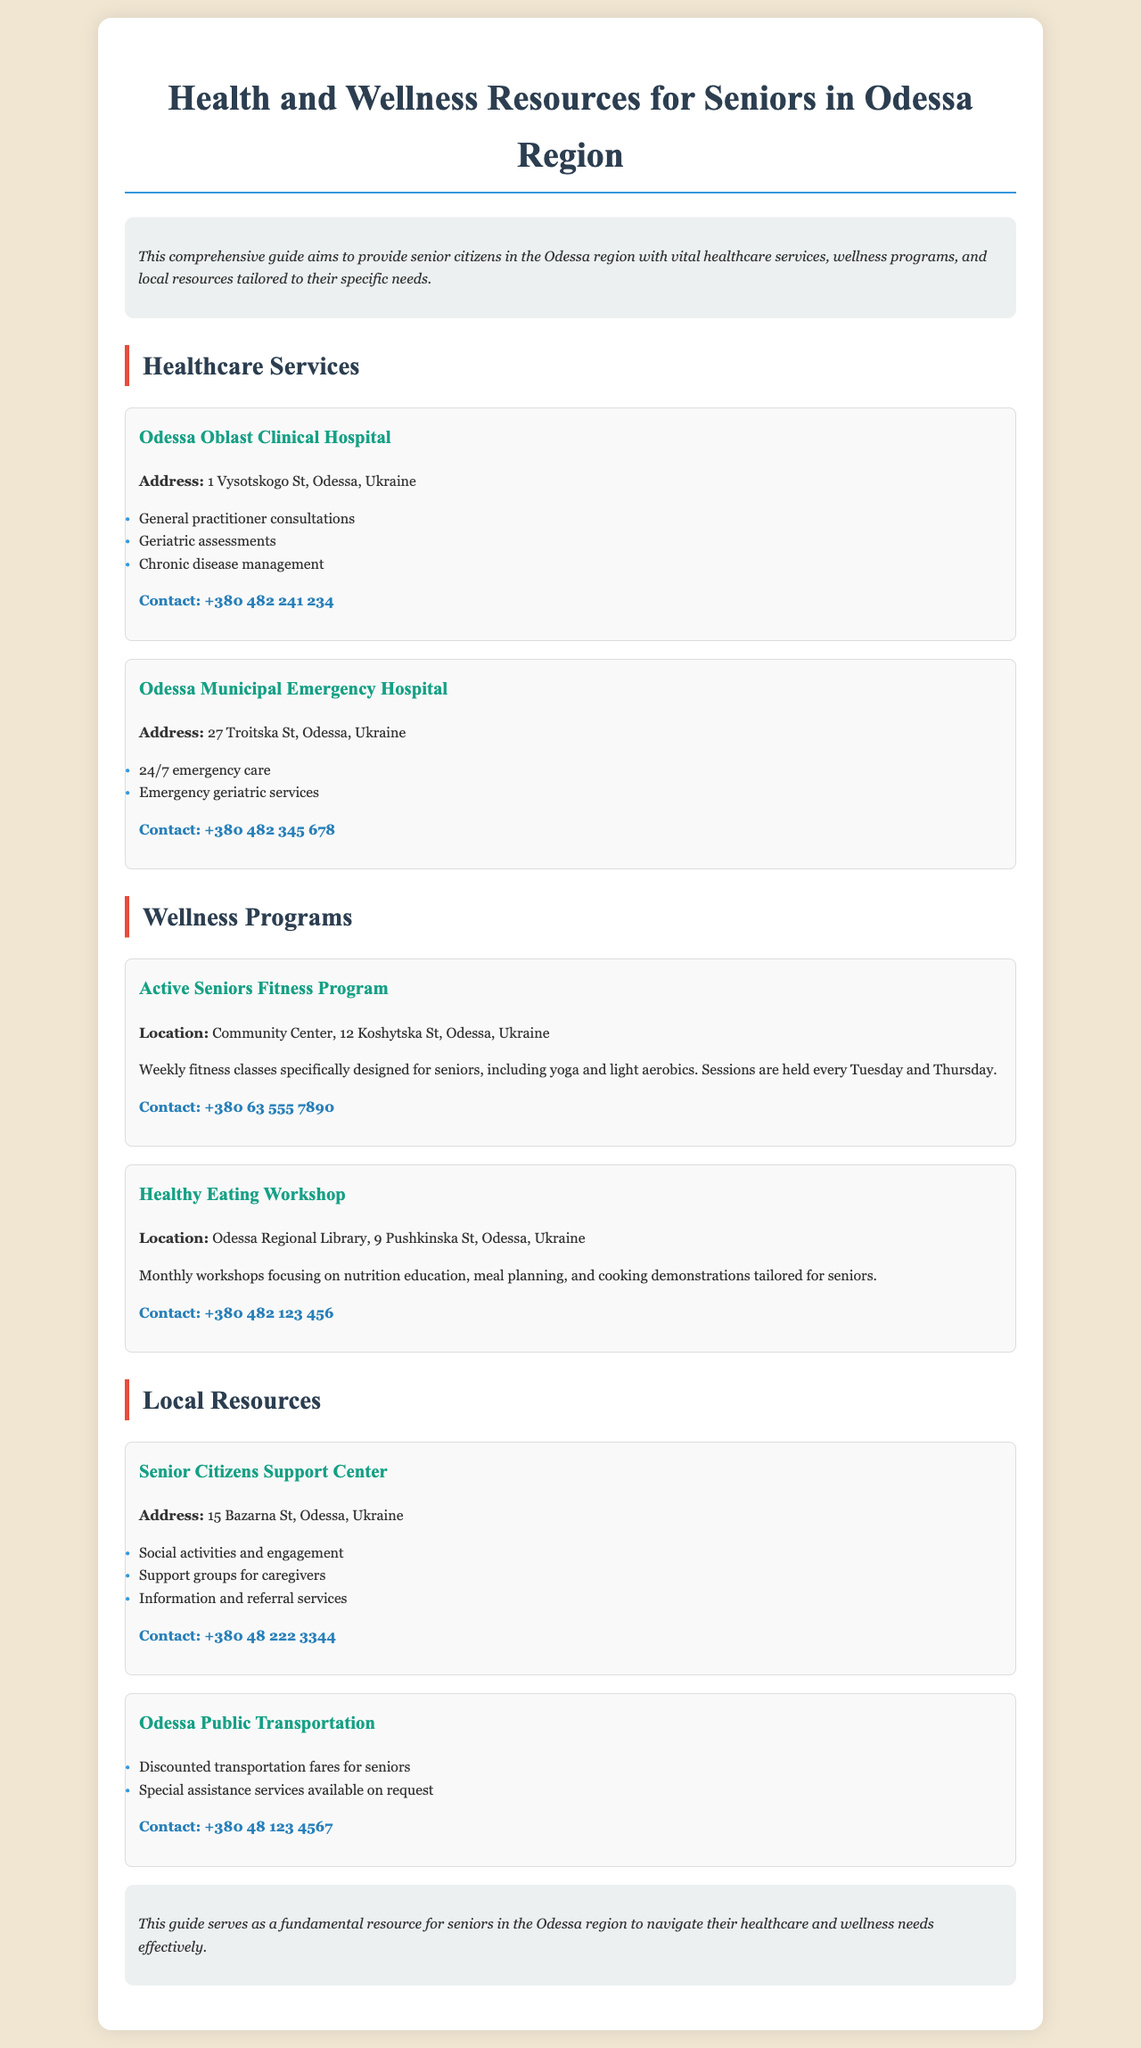What is the address of Odessa Oblast Clinical Hospital? The document states that the address of Odessa Oblast Clinical Hospital is 1 Vysotskogo St, Odessa, Ukraine.
Answer: 1 Vysotskogo St, Odessa, Ukraine What services are offered at the Odessa Municipal Emergency Hospital? The document lists the services provided by the Odessa Municipal Emergency Hospital as 24/7 emergency care and emergency geriatric services.
Answer: 24/7 emergency care, emergency geriatric services Where is the Active Seniors Fitness Program located? The document indicates that the Active Seniors Fitness Program takes place at the Community Center, 12 Koshytska St, Odessa, Ukraine.
Answer: Community Center, 12 Koshytska St, Odessa, Ukraine How often are the Healthy Eating Workshops held? The document specifies that the Healthy Eating Workshops are conducted monthly.
Answer: Monthly What type of discount does Odessa Public Transportation offer for seniors? The document mentions that Odessa Public Transportation provides discounted transportation fares for seniors.
Answer: Discounted transportation fares What is the contact number for the Senior Citizens Support Center? The document provides the contact number for the Senior Citizens Support Center as +380 48 222 3344.
Answer: +380 48 222 3344 What types of activities does the Senior Citizens Support Center offer? The document states that the Senior Citizens Support Center offers social activities and engagement, support groups for caregivers, and information and referral services.
Answer: Social activities and engagement, support groups for caregivers, information and referral services On which days are fitness classes held in the Active Seniors Fitness Program? The document mentions that fitness classes for the Active Seniors Fitness Program are held every Tuesday and Thursday.
Answer: Tuesday and Thursday 